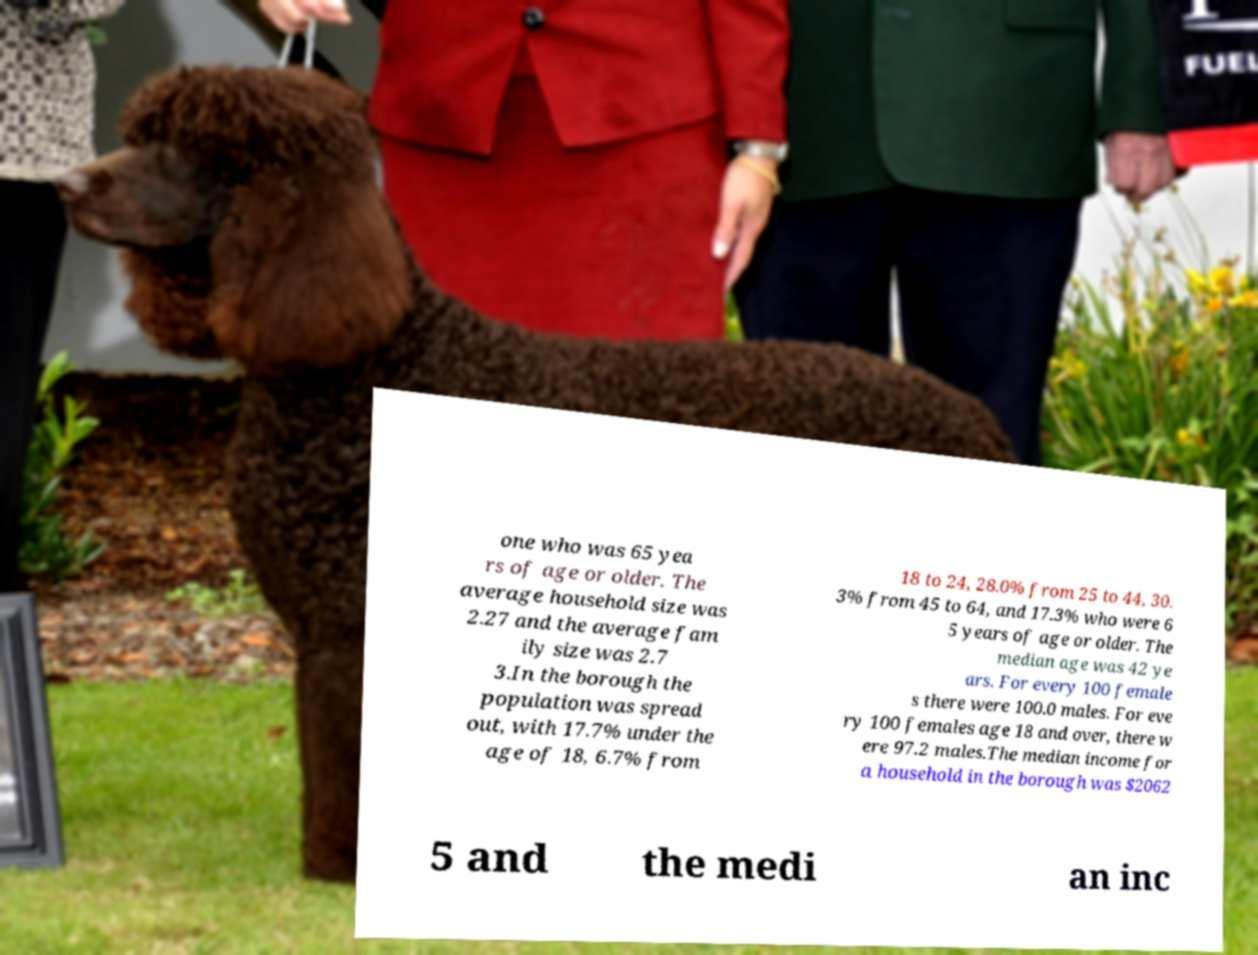Please identify and transcribe the text found in this image. one who was 65 yea rs of age or older. The average household size was 2.27 and the average fam ily size was 2.7 3.In the borough the population was spread out, with 17.7% under the age of 18, 6.7% from 18 to 24, 28.0% from 25 to 44, 30. 3% from 45 to 64, and 17.3% who were 6 5 years of age or older. The median age was 42 ye ars. For every 100 female s there were 100.0 males. For eve ry 100 females age 18 and over, there w ere 97.2 males.The median income for a household in the borough was $2062 5 and the medi an inc 